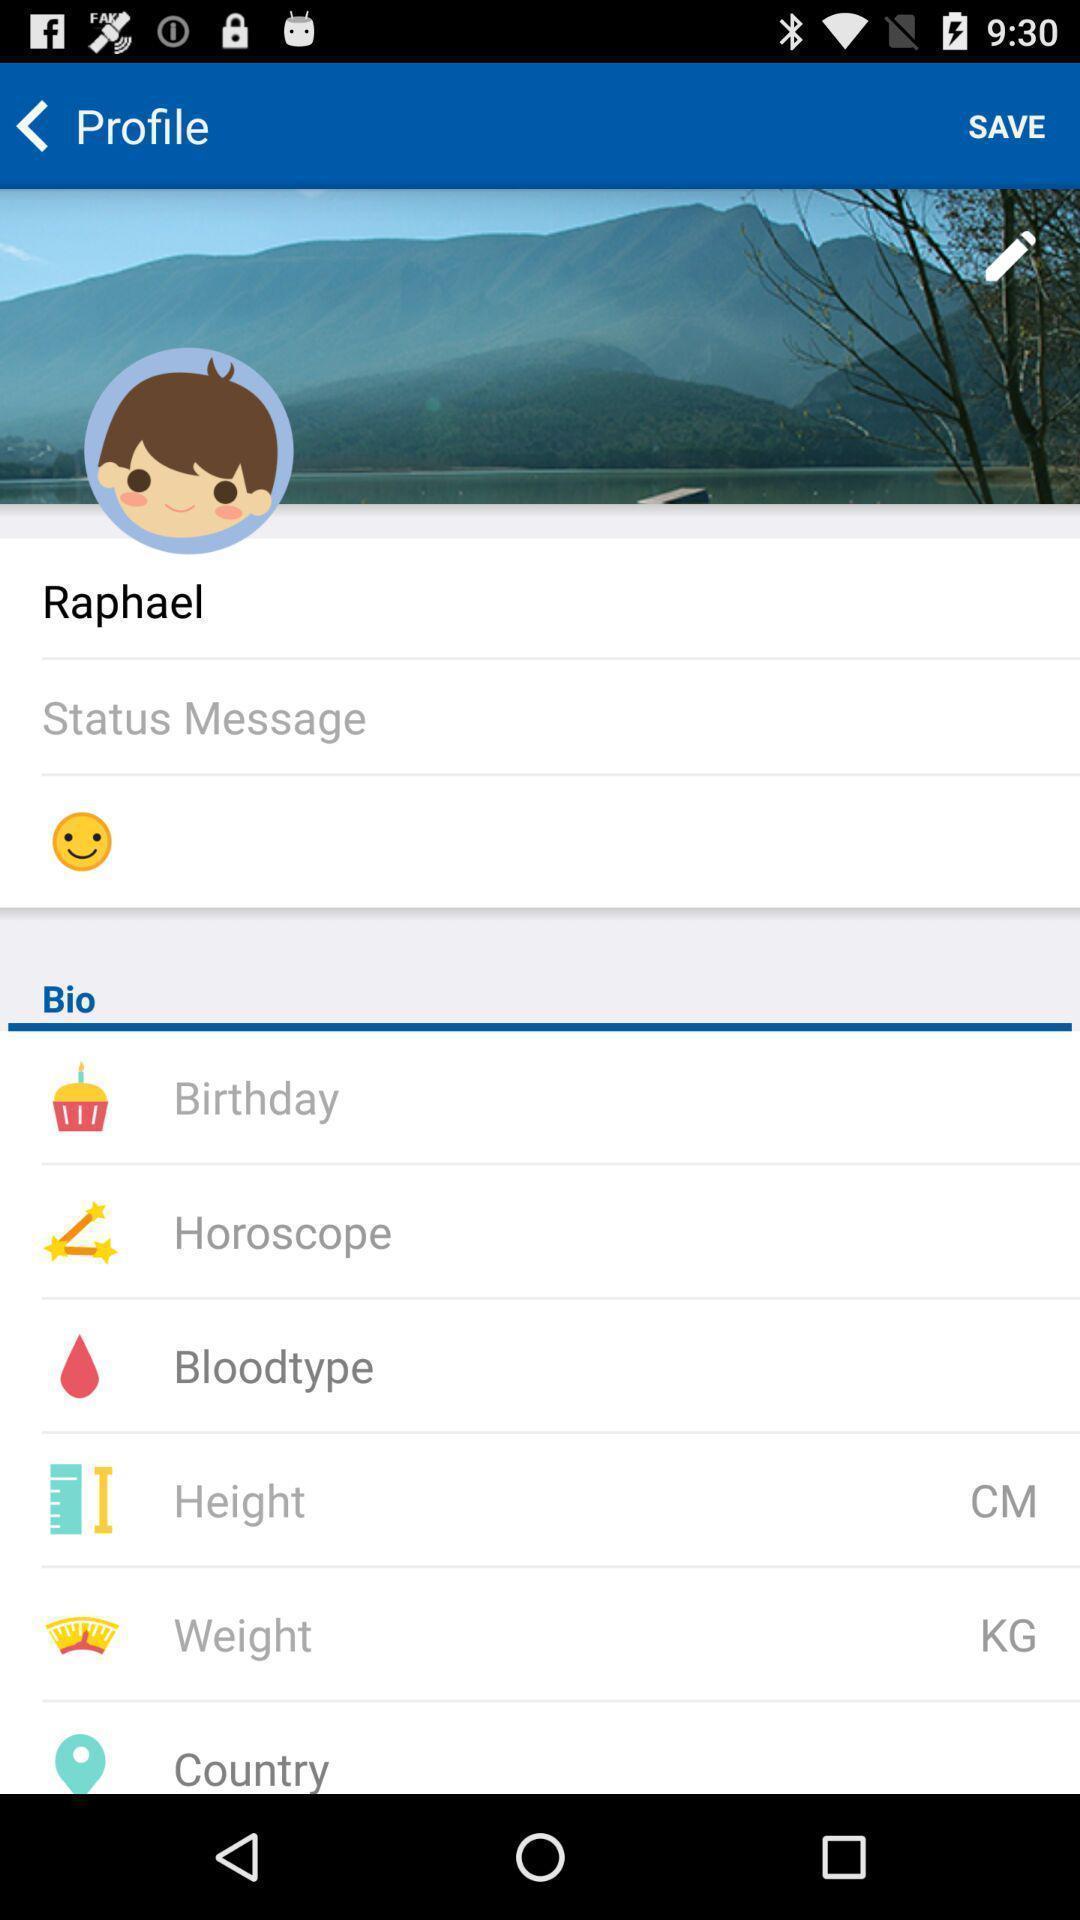Provide a detailed account of this screenshot. Screen shows profile with edit options. 